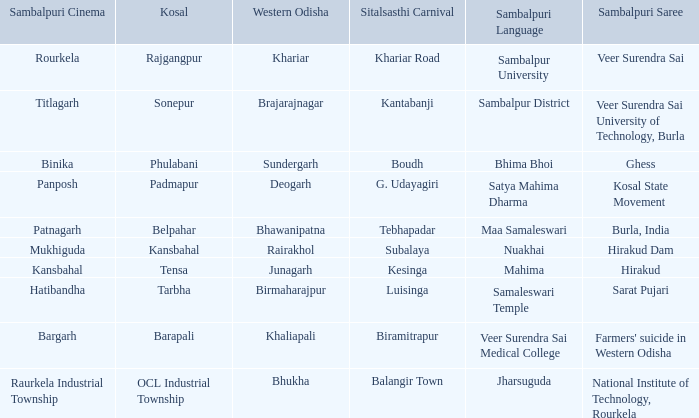What is the kosal with a balangir town sitalsasthi festival? OCL Industrial Township. 